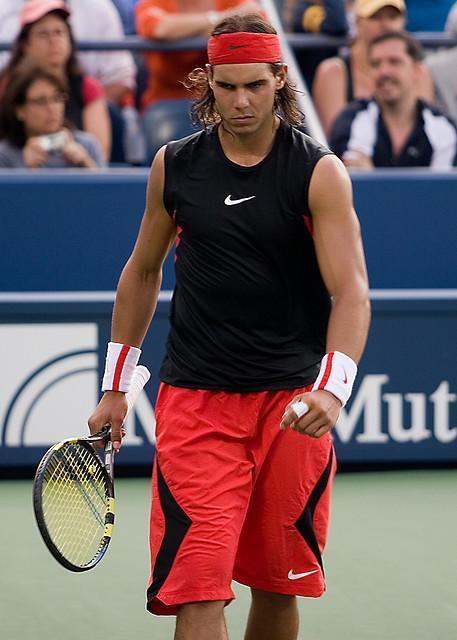How many people are there?
Give a very brief answer. 8. How many motorcycles are there?
Give a very brief answer. 0. 